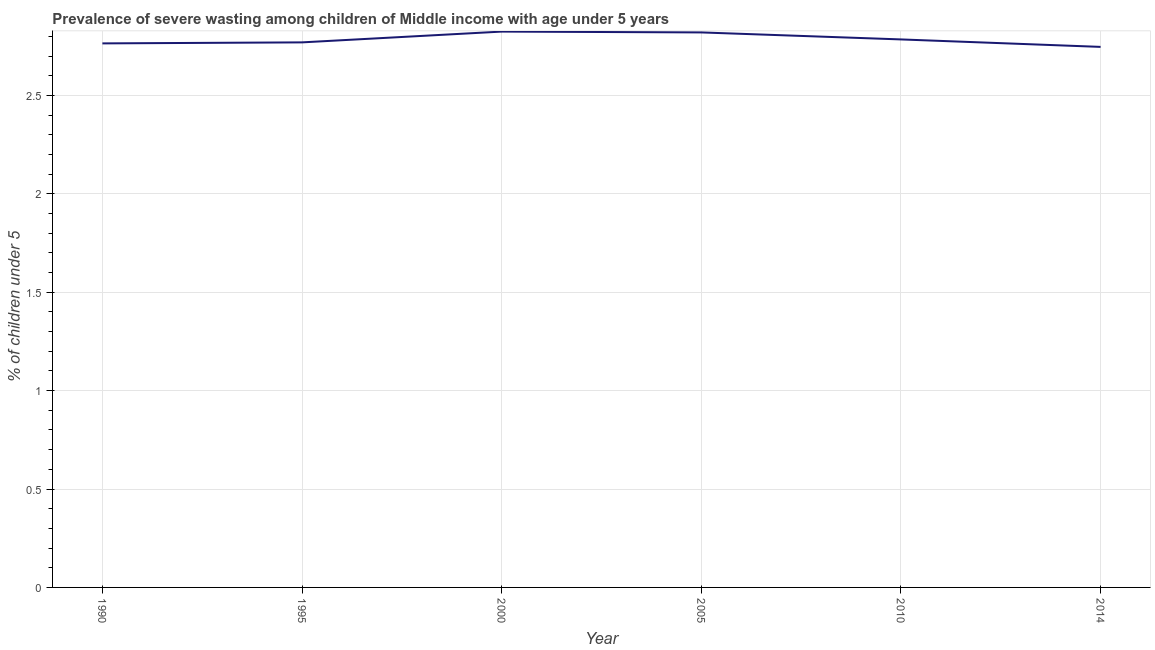What is the prevalence of severe wasting in 2005?
Your answer should be compact. 2.82. Across all years, what is the maximum prevalence of severe wasting?
Your answer should be very brief. 2.82. Across all years, what is the minimum prevalence of severe wasting?
Provide a short and direct response. 2.75. In which year was the prevalence of severe wasting maximum?
Keep it short and to the point. 2000. In which year was the prevalence of severe wasting minimum?
Offer a very short reply. 2014. What is the sum of the prevalence of severe wasting?
Your response must be concise. 16.71. What is the difference between the prevalence of severe wasting in 1995 and 2000?
Your answer should be compact. -0.05. What is the average prevalence of severe wasting per year?
Ensure brevity in your answer.  2.79. What is the median prevalence of severe wasting?
Offer a terse response. 2.78. In how many years, is the prevalence of severe wasting greater than 0.6 %?
Offer a terse response. 6. What is the ratio of the prevalence of severe wasting in 2005 to that in 2014?
Offer a very short reply. 1.03. Is the prevalence of severe wasting in 1990 less than that in 2014?
Give a very brief answer. No. Is the difference between the prevalence of severe wasting in 2000 and 2005 greater than the difference between any two years?
Make the answer very short. No. What is the difference between the highest and the second highest prevalence of severe wasting?
Make the answer very short. 0. What is the difference between the highest and the lowest prevalence of severe wasting?
Your answer should be compact. 0.08. In how many years, is the prevalence of severe wasting greater than the average prevalence of severe wasting taken over all years?
Your response must be concise. 2. How many lines are there?
Ensure brevity in your answer.  1. What is the difference between two consecutive major ticks on the Y-axis?
Provide a short and direct response. 0.5. Does the graph contain grids?
Offer a very short reply. Yes. What is the title of the graph?
Keep it short and to the point. Prevalence of severe wasting among children of Middle income with age under 5 years. What is the label or title of the X-axis?
Your answer should be compact. Year. What is the label or title of the Y-axis?
Offer a very short reply.  % of children under 5. What is the  % of children under 5 in 1990?
Your answer should be compact. 2.76. What is the  % of children under 5 in 1995?
Make the answer very short. 2.77. What is the  % of children under 5 in 2000?
Make the answer very short. 2.82. What is the  % of children under 5 of 2005?
Your answer should be compact. 2.82. What is the  % of children under 5 in 2010?
Keep it short and to the point. 2.78. What is the  % of children under 5 of 2014?
Ensure brevity in your answer.  2.75. What is the difference between the  % of children under 5 in 1990 and 1995?
Your answer should be very brief. -0.01. What is the difference between the  % of children under 5 in 1990 and 2000?
Provide a succinct answer. -0.06. What is the difference between the  % of children under 5 in 1990 and 2005?
Keep it short and to the point. -0.06. What is the difference between the  % of children under 5 in 1990 and 2010?
Provide a short and direct response. -0.02. What is the difference between the  % of children under 5 in 1990 and 2014?
Make the answer very short. 0.02. What is the difference between the  % of children under 5 in 1995 and 2000?
Your response must be concise. -0.05. What is the difference between the  % of children under 5 in 1995 and 2005?
Give a very brief answer. -0.05. What is the difference between the  % of children under 5 in 1995 and 2010?
Give a very brief answer. -0.02. What is the difference between the  % of children under 5 in 1995 and 2014?
Your answer should be very brief. 0.02. What is the difference between the  % of children under 5 in 2000 and 2005?
Provide a short and direct response. 0. What is the difference between the  % of children under 5 in 2000 and 2010?
Make the answer very short. 0.04. What is the difference between the  % of children under 5 in 2000 and 2014?
Offer a terse response. 0.08. What is the difference between the  % of children under 5 in 2005 and 2010?
Ensure brevity in your answer.  0.04. What is the difference between the  % of children under 5 in 2005 and 2014?
Ensure brevity in your answer.  0.07. What is the difference between the  % of children under 5 in 2010 and 2014?
Provide a short and direct response. 0.04. What is the ratio of the  % of children under 5 in 1990 to that in 1995?
Give a very brief answer. 1. What is the ratio of the  % of children under 5 in 1990 to that in 2000?
Ensure brevity in your answer.  0.98. What is the ratio of the  % of children under 5 in 1990 to that in 2014?
Provide a succinct answer. 1.01. What is the ratio of the  % of children under 5 in 1995 to that in 2000?
Your answer should be compact. 0.98. What is the ratio of the  % of children under 5 in 1995 to that in 2010?
Ensure brevity in your answer.  0.99. What is the ratio of the  % of children under 5 in 1995 to that in 2014?
Your answer should be compact. 1.01. What is the ratio of the  % of children under 5 in 2000 to that in 2010?
Your answer should be very brief. 1.01. What is the ratio of the  % of children under 5 in 2000 to that in 2014?
Give a very brief answer. 1.03. What is the ratio of the  % of children under 5 in 2005 to that in 2010?
Make the answer very short. 1.01. What is the ratio of the  % of children under 5 in 2005 to that in 2014?
Your answer should be very brief. 1.03. 